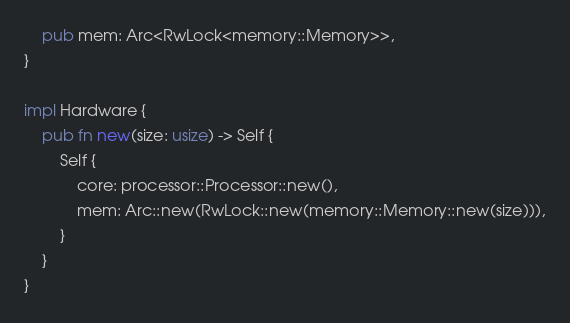Convert code to text. <code><loc_0><loc_0><loc_500><loc_500><_Rust_>    pub mem: Arc<RwLock<memory::Memory>>,
}

impl Hardware {
    pub fn new(size: usize) -> Self {
        Self {
            core: processor::Processor::new(),
            mem: Arc::new(RwLock::new(memory::Memory::new(size))),
        }
    }
}</code> 